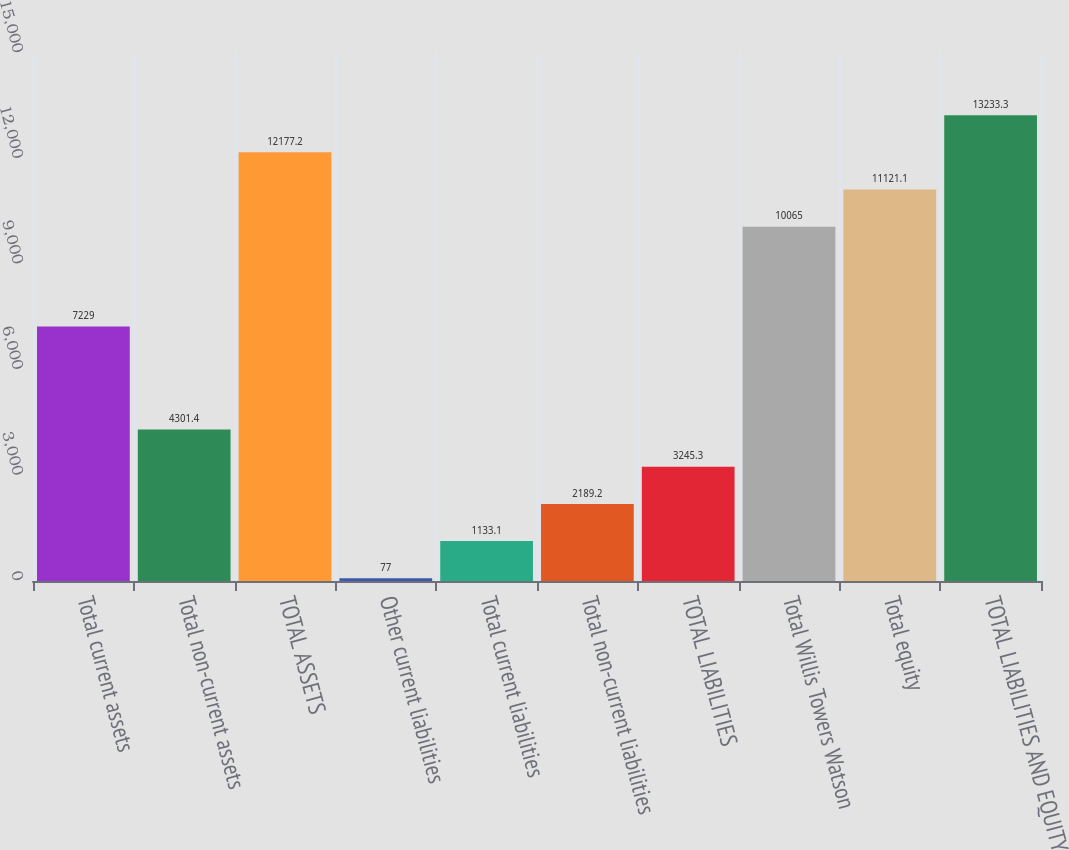Convert chart. <chart><loc_0><loc_0><loc_500><loc_500><bar_chart><fcel>Total current assets<fcel>Total non-current assets<fcel>TOTAL ASSETS<fcel>Other current liabilities<fcel>Total current liabilities<fcel>Total non-current liabilities<fcel>TOTAL LIABILITIES<fcel>Total Willis Towers Watson<fcel>Total equity<fcel>TOTAL LIABILITIES AND EQUITY<nl><fcel>7229<fcel>4301.4<fcel>12177.2<fcel>77<fcel>1133.1<fcel>2189.2<fcel>3245.3<fcel>10065<fcel>11121.1<fcel>13233.3<nl></chart> 